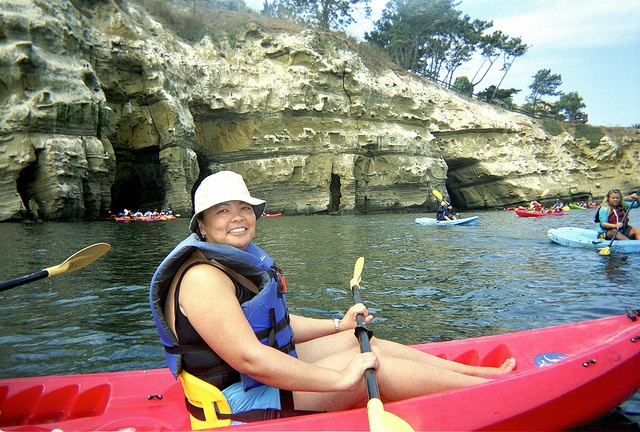Describe the objects in this image and their specific colors. I can see people in beige, tan, black, and ivory tones, boat in beige, salmon, maroon, and brown tones, boat in beige, lightblue, and teal tones, people in beige, black, gray, maroon, and tan tones, and boat in beige, lightblue, ivory, and gray tones in this image. 